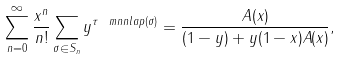Convert formula to latex. <formula><loc_0><loc_0><loc_500><loc_500>\sum _ { n = 0 } ^ { \infty } \frac { x ^ { n } } { n ! } \sum _ { \sigma \in S _ { n } } y ^ { \tau \ m n n l a p ( \sigma ) } = \frac { A ( x ) } { ( 1 - y ) + y ( 1 - x ) A ( x ) } ,</formula> 